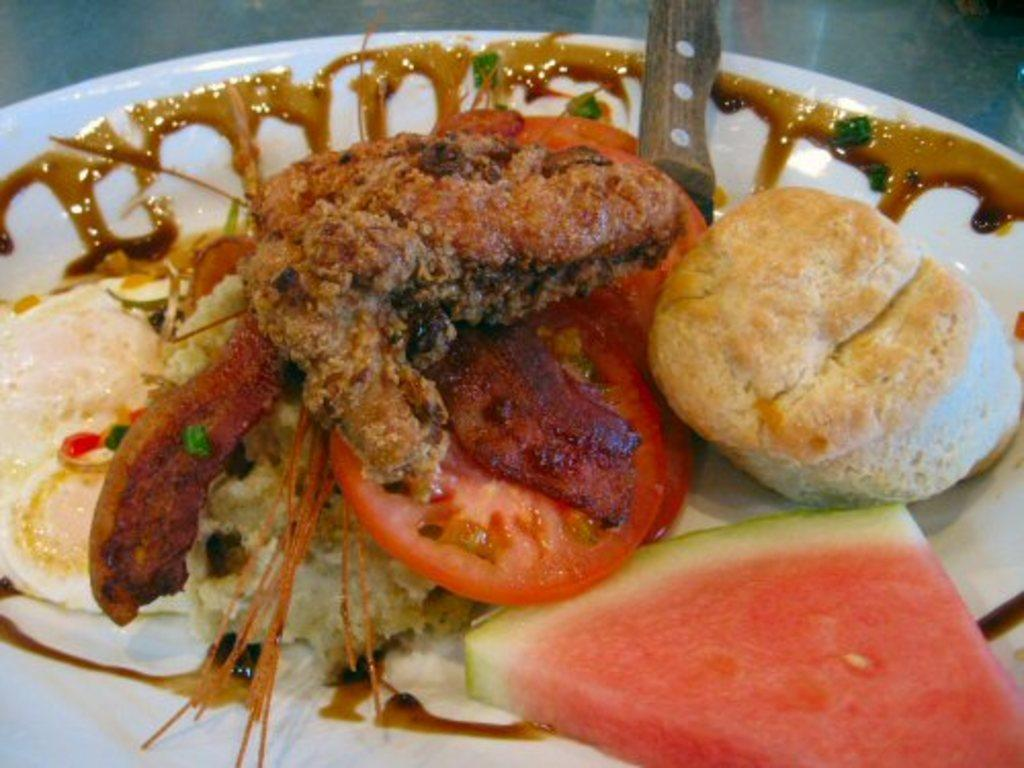What is on the plate that is visible in the image? The plate contains a piece of watermelon and tomato slices. Are there any other food items on the plate? Yes, there are other food items on the plate. What object in the image might be used for cutting the food? There is an object that resembles a knife in the image. What type of mist can be seen covering the town in the image? There is no town or mist present in the image; it features a plate with food items and a knife-like object. What type of sponge is being used to clean the plate in the image? There is no sponge visible in the image, and the plate is not being cleaned. 